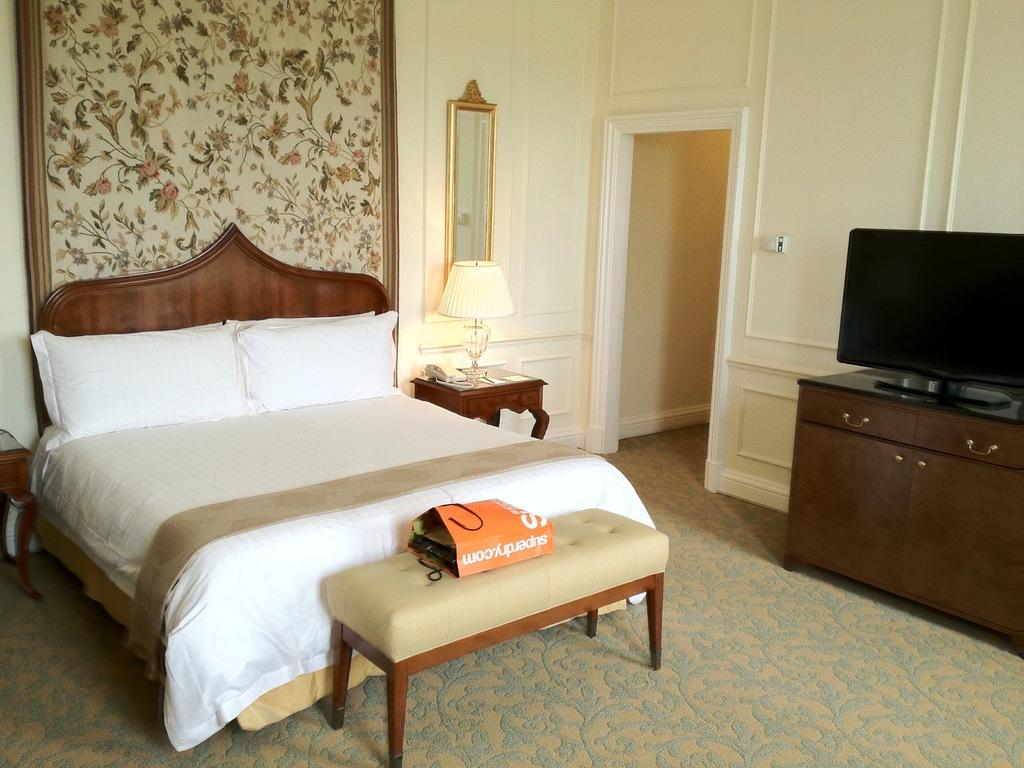What type of space is shown in the image? The image is of the inside of a room. What furniture is present in the room? There is a bed, a lamp, and a table in the room. What is on the table in the room? There is a monitor on the table. What is covering something in the room? There is a cover in the room. What can be seen on the walls in the background of the image? The background of the image includes a wall. How many crows are sitting on the lamp in the image? There are no crows present in the image; the lamp is not associated with any birds. 